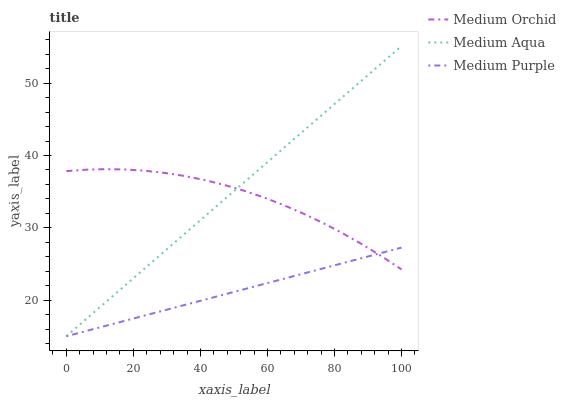Does Medium Purple have the minimum area under the curve?
Answer yes or no. Yes. Does Medium Aqua have the maximum area under the curve?
Answer yes or no. Yes. Does Medium Orchid have the minimum area under the curve?
Answer yes or no. No. Does Medium Orchid have the maximum area under the curve?
Answer yes or no. No. Is Medium Purple the smoothest?
Answer yes or no. Yes. Is Medium Orchid the roughest?
Answer yes or no. Yes. Is Medium Aqua the smoothest?
Answer yes or no. No. Is Medium Aqua the roughest?
Answer yes or no. No. Does Medium Orchid have the lowest value?
Answer yes or no. No. Does Medium Aqua have the highest value?
Answer yes or no. Yes. Does Medium Orchid have the highest value?
Answer yes or no. No. Does Medium Purple intersect Medium Orchid?
Answer yes or no. Yes. Is Medium Purple less than Medium Orchid?
Answer yes or no. No. Is Medium Purple greater than Medium Orchid?
Answer yes or no. No. 